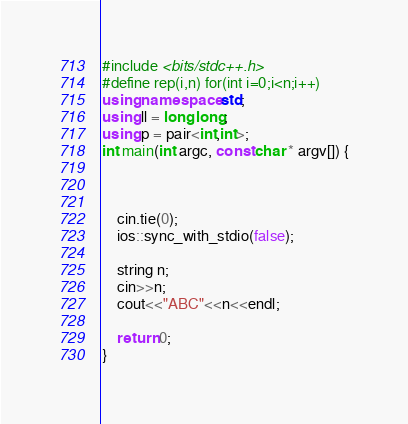Convert code to text. <code><loc_0><loc_0><loc_500><loc_500><_C++_>#include <bits/stdc++.h>
#define rep(i,n) for(int i=0;i<n;i++)
using namespace std;
using ll = long long;
using p = pair<int,int>;
int main(int argc, const char * argv[]) {



    cin.tie(0);
    ios::sync_with_stdio(false);

    string n;
    cin>>n;
    cout<<"ABC"<<n<<endl;

    return 0;
}
</code> 